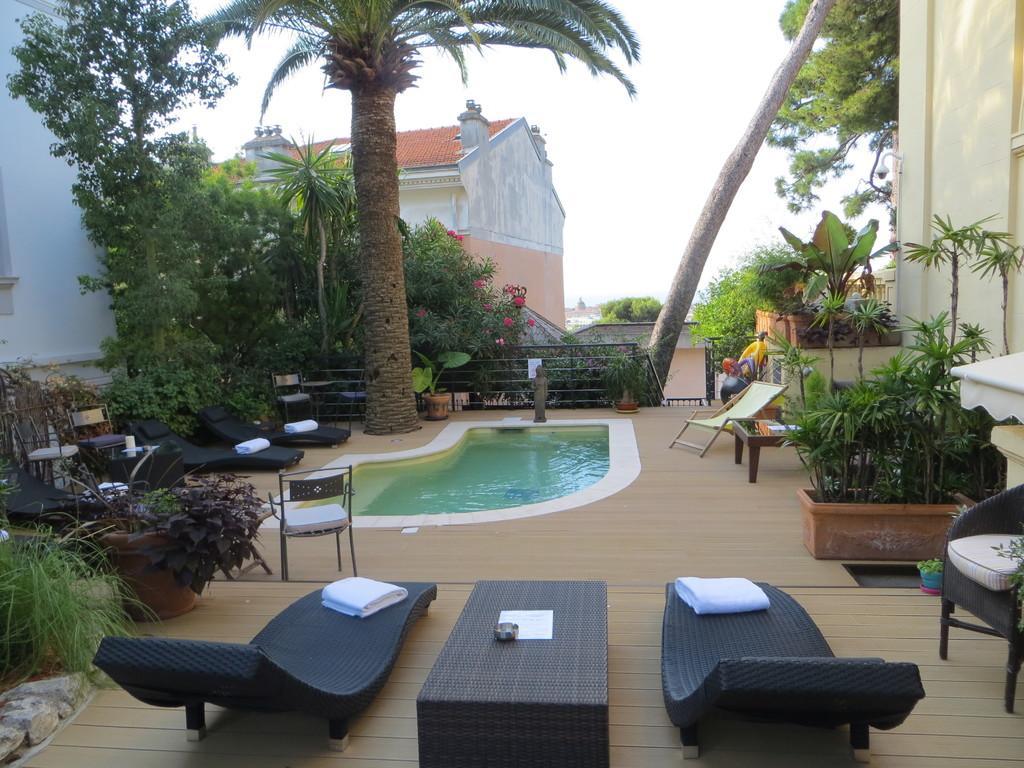Can you describe this image briefly? In this image, we can see a small swimming pool, there are some green color plants and trees, at the top there is a sky. 